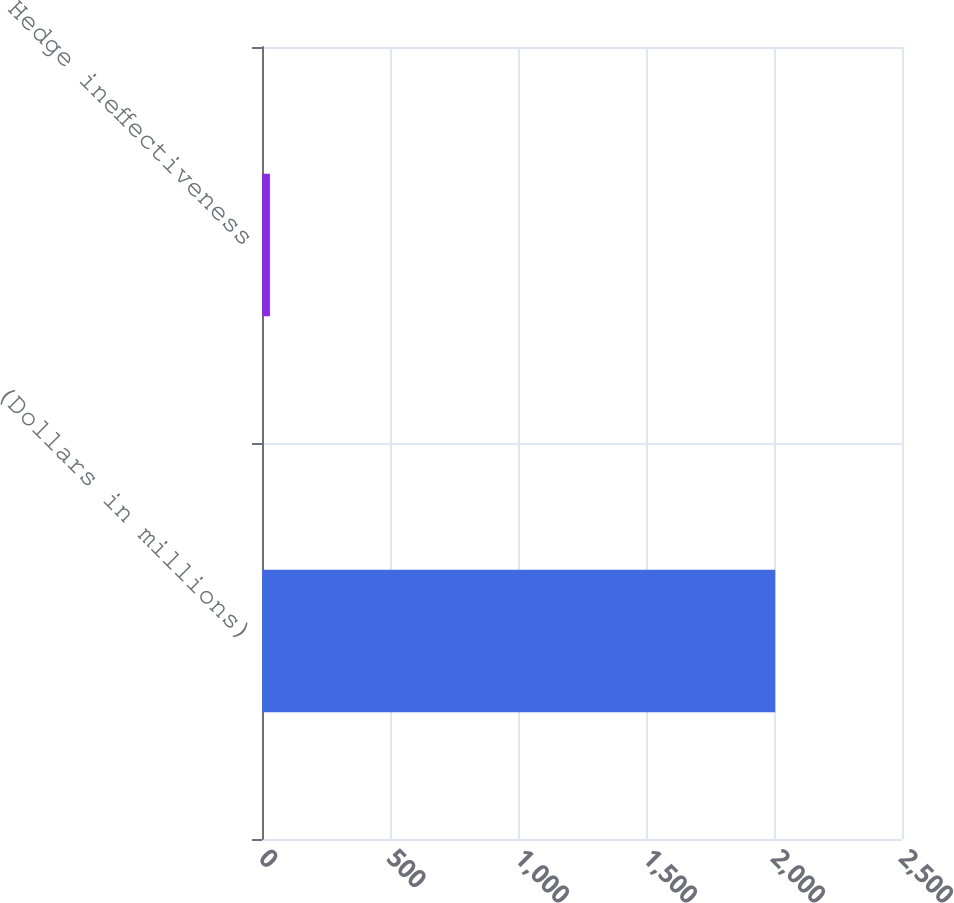Convert chart to OTSL. <chart><loc_0><loc_0><loc_500><loc_500><bar_chart><fcel>(Dollars in millions)<fcel>Hedge ineffectiveness<nl><fcel>2005<fcel>31<nl></chart> 